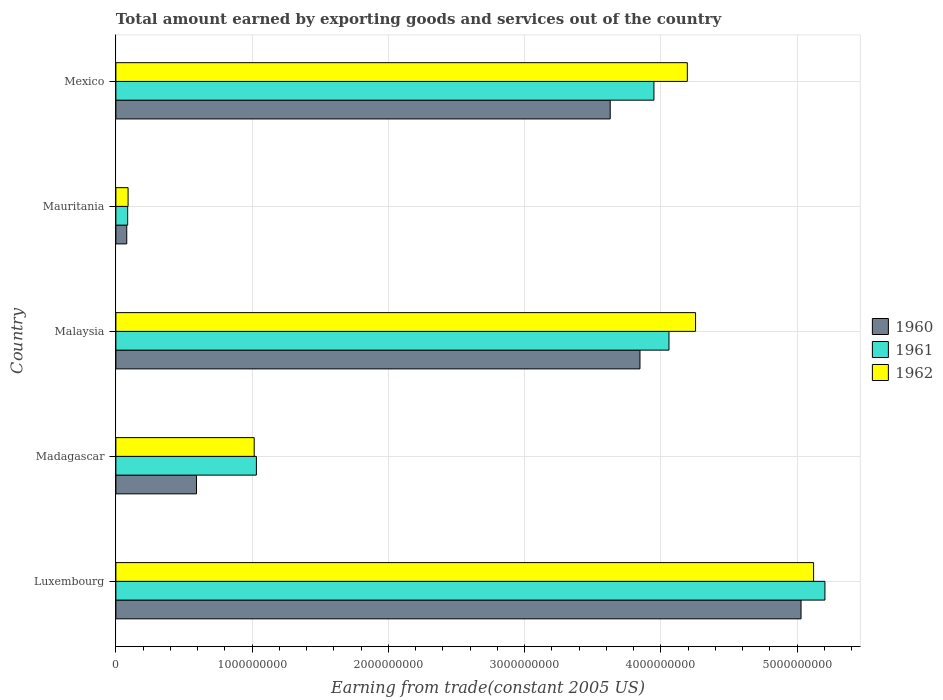Are the number of bars on each tick of the Y-axis equal?
Provide a short and direct response. Yes. How many bars are there on the 2nd tick from the top?
Make the answer very short. 3. What is the label of the 5th group of bars from the top?
Your answer should be compact. Luxembourg. What is the total amount earned by exporting goods and services in 1961 in Madagascar?
Ensure brevity in your answer.  1.03e+09. Across all countries, what is the maximum total amount earned by exporting goods and services in 1962?
Your response must be concise. 5.12e+09. Across all countries, what is the minimum total amount earned by exporting goods and services in 1962?
Your answer should be very brief. 8.95e+07. In which country was the total amount earned by exporting goods and services in 1961 maximum?
Your response must be concise. Luxembourg. In which country was the total amount earned by exporting goods and services in 1962 minimum?
Your answer should be compact. Mauritania. What is the total total amount earned by exporting goods and services in 1960 in the graph?
Your answer should be compact. 1.32e+1. What is the difference between the total amount earned by exporting goods and services in 1961 in Madagascar and that in Mexico?
Keep it short and to the point. -2.92e+09. What is the difference between the total amount earned by exporting goods and services in 1960 in Luxembourg and the total amount earned by exporting goods and services in 1962 in Mexico?
Keep it short and to the point. 8.35e+08. What is the average total amount earned by exporting goods and services in 1962 per country?
Offer a terse response. 2.94e+09. What is the difference between the total amount earned by exporting goods and services in 1962 and total amount earned by exporting goods and services in 1960 in Luxembourg?
Make the answer very short. 9.22e+07. In how many countries, is the total amount earned by exporting goods and services in 1961 greater than 4200000000 US$?
Keep it short and to the point. 1. What is the ratio of the total amount earned by exporting goods and services in 1962 in Malaysia to that in Mauritania?
Offer a very short reply. 47.53. Is the total amount earned by exporting goods and services in 1961 in Madagascar less than that in Malaysia?
Your answer should be compact. Yes. Is the difference between the total amount earned by exporting goods and services in 1962 in Malaysia and Mauritania greater than the difference between the total amount earned by exporting goods and services in 1960 in Malaysia and Mauritania?
Give a very brief answer. Yes. What is the difference between the highest and the second highest total amount earned by exporting goods and services in 1960?
Offer a terse response. 1.18e+09. What is the difference between the highest and the lowest total amount earned by exporting goods and services in 1961?
Provide a short and direct response. 5.12e+09. In how many countries, is the total amount earned by exporting goods and services in 1960 greater than the average total amount earned by exporting goods and services in 1960 taken over all countries?
Make the answer very short. 3. What does the 1st bar from the top in Malaysia represents?
Make the answer very short. 1962. What does the 3rd bar from the bottom in Mexico represents?
Offer a terse response. 1962. Is it the case that in every country, the sum of the total amount earned by exporting goods and services in 1960 and total amount earned by exporting goods and services in 1961 is greater than the total amount earned by exporting goods and services in 1962?
Provide a succinct answer. Yes. How many countries are there in the graph?
Keep it short and to the point. 5. What is the difference between two consecutive major ticks on the X-axis?
Your answer should be compact. 1.00e+09. Are the values on the major ticks of X-axis written in scientific E-notation?
Your response must be concise. No. What is the title of the graph?
Make the answer very short. Total amount earned by exporting goods and services out of the country. What is the label or title of the X-axis?
Your response must be concise. Earning from trade(constant 2005 US). What is the label or title of the Y-axis?
Provide a succinct answer. Country. What is the Earning from trade(constant 2005 US) of 1960 in Luxembourg?
Offer a very short reply. 5.03e+09. What is the Earning from trade(constant 2005 US) of 1961 in Luxembourg?
Your answer should be compact. 5.20e+09. What is the Earning from trade(constant 2005 US) in 1962 in Luxembourg?
Give a very brief answer. 5.12e+09. What is the Earning from trade(constant 2005 US) of 1960 in Madagascar?
Your answer should be very brief. 5.92e+08. What is the Earning from trade(constant 2005 US) of 1961 in Madagascar?
Your answer should be very brief. 1.03e+09. What is the Earning from trade(constant 2005 US) in 1962 in Madagascar?
Provide a succinct answer. 1.02e+09. What is the Earning from trade(constant 2005 US) in 1960 in Malaysia?
Your answer should be very brief. 3.85e+09. What is the Earning from trade(constant 2005 US) of 1961 in Malaysia?
Keep it short and to the point. 4.06e+09. What is the Earning from trade(constant 2005 US) in 1962 in Malaysia?
Your response must be concise. 4.25e+09. What is the Earning from trade(constant 2005 US) in 1960 in Mauritania?
Offer a terse response. 7.97e+07. What is the Earning from trade(constant 2005 US) of 1961 in Mauritania?
Provide a short and direct response. 8.64e+07. What is the Earning from trade(constant 2005 US) in 1962 in Mauritania?
Your response must be concise. 8.95e+07. What is the Earning from trade(constant 2005 US) of 1960 in Mexico?
Your response must be concise. 3.63e+09. What is the Earning from trade(constant 2005 US) in 1961 in Mexico?
Your answer should be compact. 3.95e+09. What is the Earning from trade(constant 2005 US) of 1962 in Mexico?
Ensure brevity in your answer.  4.19e+09. Across all countries, what is the maximum Earning from trade(constant 2005 US) in 1960?
Your answer should be very brief. 5.03e+09. Across all countries, what is the maximum Earning from trade(constant 2005 US) in 1961?
Make the answer very short. 5.20e+09. Across all countries, what is the maximum Earning from trade(constant 2005 US) in 1962?
Provide a short and direct response. 5.12e+09. Across all countries, what is the minimum Earning from trade(constant 2005 US) of 1960?
Your response must be concise. 7.97e+07. Across all countries, what is the minimum Earning from trade(constant 2005 US) in 1961?
Offer a very short reply. 8.64e+07. Across all countries, what is the minimum Earning from trade(constant 2005 US) in 1962?
Your answer should be very brief. 8.95e+07. What is the total Earning from trade(constant 2005 US) of 1960 in the graph?
Ensure brevity in your answer.  1.32e+1. What is the total Earning from trade(constant 2005 US) of 1961 in the graph?
Your answer should be very brief. 1.43e+1. What is the total Earning from trade(constant 2005 US) in 1962 in the graph?
Keep it short and to the point. 1.47e+1. What is the difference between the Earning from trade(constant 2005 US) in 1960 in Luxembourg and that in Madagascar?
Give a very brief answer. 4.44e+09. What is the difference between the Earning from trade(constant 2005 US) in 1961 in Luxembourg and that in Madagascar?
Provide a succinct answer. 4.17e+09. What is the difference between the Earning from trade(constant 2005 US) of 1962 in Luxembourg and that in Madagascar?
Offer a very short reply. 4.11e+09. What is the difference between the Earning from trade(constant 2005 US) in 1960 in Luxembourg and that in Malaysia?
Ensure brevity in your answer.  1.18e+09. What is the difference between the Earning from trade(constant 2005 US) in 1961 in Luxembourg and that in Malaysia?
Provide a short and direct response. 1.14e+09. What is the difference between the Earning from trade(constant 2005 US) of 1962 in Luxembourg and that in Malaysia?
Give a very brief answer. 8.66e+08. What is the difference between the Earning from trade(constant 2005 US) in 1960 in Luxembourg and that in Mauritania?
Provide a succinct answer. 4.95e+09. What is the difference between the Earning from trade(constant 2005 US) of 1961 in Luxembourg and that in Mauritania?
Keep it short and to the point. 5.12e+09. What is the difference between the Earning from trade(constant 2005 US) of 1962 in Luxembourg and that in Mauritania?
Keep it short and to the point. 5.03e+09. What is the difference between the Earning from trade(constant 2005 US) in 1960 in Luxembourg and that in Mexico?
Your response must be concise. 1.40e+09. What is the difference between the Earning from trade(constant 2005 US) in 1961 in Luxembourg and that in Mexico?
Make the answer very short. 1.26e+09. What is the difference between the Earning from trade(constant 2005 US) in 1962 in Luxembourg and that in Mexico?
Your answer should be compact. 9.27e+08. What is the difference between the Earning from trade(constant 2005 US) of 1960 in Madagascar and that in Malaysia?
Provide a short and direct response. -3.26e+09. What is the difference between the Earning from trade(constant 2005 US) in 1961 in Madagascar and that in Malaysia?
Offer a terse response. -3.03e+09. What is the difference between the Earning from trade(constant 2005 US) in 1962 in Madagascar and that in Malaysia?
Make the answer very short. -3.24e+09. What is the difference between the Earning from trade(constant 2005 US) in 1960 in Madagascar and that in Mauritania?
Your answer should be compact. 5.12e+08. What is the difference between the Earning from trade(constant 2005 US) of 1961 in Madagascar and that in Mauritania?
Give a very brief answer. 9.45e+08. What is the difference between the Earning from trade(constant 2005 US) of 1962 in Madagascar and that in Mauritania?
Your answer should be compact. 9.26e+08. What is the difference between the Earning from trade(constant 2005 US) of 1960 in Madagascar and that in Mexico?
Your response must be concise. -3.04e+09. What is the difference between the Earning from trade(constant 2005 US) of 1961 in Madagascar and that in Mexico?
Your answer should be compact. -2.92e+09. What is the difference between the Earning from trade(constant 2005 US) of 1962 in Madagascar and that in Mexico?
Ensure brevity in your answer.  -3.18e+09. What is the difference between the Earning from trade(constant 2005 US) in 1960 in Malaysia and that in Mauritania?
Make the answer very short. 3.77e+09. What is the difference between the Earning from trade(constant 2005 US) in 1961 in Malaysia and that in Mauritania?
Offer a terse response. 3.97e+09. What is the difference between the Earning from trade(constant 2005 US) in 1962 in Malaysia and that in Mauritania?
Provide a short and direct response. 4.17e+09. What is the difference between the Earning from trade(constant 2005 US) of 1960 in Malaysia and that in Mexico?
Your response must be concise. 2.18e+08. What is the difference between the Earning from trade(constant 2005 US) in 1961 in Malaysia and that in Mexico?
Provide a succinct answer. 1.10e+08. What is the difference between the Earning from trade(constant 2005 US) of 1962 in Malaysia and that in Mexico?
Provide a succinct answer. 6.04e+07. What is the difference between the Earning from trade(constant 2005 US) of 1960 in Mauritania and that in Mexico?
Make the answer very short. -3.55e+09. What is the difference between the Earning from trade(constant 2005 US) of 1961 in Mauritania and that in Mexico?
Your response must be concise. -3.86e+09. What is the difference between the Earning from trade(constant 2005 US) of 1962 in Mauritania and that in Mexico?
Provide a short and direct response. -4.10e+09. What is the difference between the Earning from trade(constant 2005 US) of 1960 in Luxembourg and the Earning from trade(constant 2005 US) of 1961 in Madagascar?
Ensure brevity in your answer.  4.00e+09. What is the difference between the Earning from trade(constant 2005 US) of 1960 in Luxembourg and the Earning from trade(constant 2005 US) of 1962 in Madagascar?
Give a very brief answer. 4.01e+09. What is the difference between the Earning from trade(constant 2005 US) in 1961 in Luxembourg and the Earning from trade(constant 2005 US) in 1962 in Madagascar?
Provide a short and direct response. 4.19e+09. What is the difference between the Earning from trade(constant 2005 US) of 1960 in Luxembourg and the Earning from trade(constant 2005 US) of 1961 in Malaysia?
Keep it short and to the point. 9.69e+08. What is the difference between the Earning from trade(constant 2005 US) in 1960 in Luxembourg and the Earning from trade(constant 2005 US) in 1962 in Malaysia?
Your answer should be very brief. 7.74e+08. What is the difference between the Earning from trade(constant 2005 US) in 1961 in Luxembourg and the Earning from trade(constant 2005 US) in 1962 in Malaysia?
Ensure brevity in your answer.  9.49e+08. What is the difference between the Earning from trade(constant 2005 US) in 1960 in Luxembourg and the Earning from trade(constant 2005 US) in 1961 in Mauritania?
Ensure brevity in your answer.  4.94e+09. What is the difference between the Earning from trade(constant 2005 US) of 1960 in Luxembourg and the Earning from trade(constant 2005 US) of 1962 in Mauritania?
Provide a short and direct response. 4.94e+09. What is the difference between the Earning from trade(constant 2005 US) of 1961 in Luxembourg and the Earning from trade(constant 2005 US) of 1962 in Mauritania?
Ensure brevity in your answer.  5.11e+09. What is the difference between the Earning from trade(constant 2005 US) of 1960 in Luxembourg and the Earning from trade(constant 2005 US) of 1961 in Mexico?
Provide a short and direct response. 1.08e+09. What is the difference between the Earning from trade(constant 2005 US) of 1960 in Luxembourg and the Earning from trade(constant 2005 US) of 1962 in Mexico?
Offer a very short reply. 8.35e+08. What is the difference between the Earning from trade(constant 2005 US) in 1961 in Luxembourg and the Earning from trade(constant 2005 US) in 1962 in Mexico?
Provide a short and direct response. 1.01e+09. What is the difference between the Earning from trade(constant 2005 US) in 1960 in Madagascar and the Earning from trade(constant 2005 US) in 1961 in Malaysia?
Your answer should be compact. -3.47e+09. What is the difference between the Earning from trade(constant 2005 US) in 1960 in Madagascar and the Earning from trade(constant 2005 US) in 1962 in Malaysia?
Keep it short and to the point. -3.66e+09. What is the difference between the Earning from trade(constant 2005 US) of 1961 in Madagascar and the Earning from trade(constant 2005 US) of 1962 in Malaysia?
Keep it short and to the point. -3.22e+09. What is the difference between the Earning from trade(constant 2005 US) of 1960 in Madagascar and the Earning from trade(constant 2005 US) of 1961 in Mauritania?
Your answer should be very brief. 5.05e+08. What is the difference between the Earning from trade(constant 2005 US) of 1960 in Madagascar and the Earning from trade(constant 2005 US) of 1962 in Mauritania?
Offer a very short reply. 5.02e+08. What is the difference between the Earning from trade(constant 2005 US) in 1961 in Madagascar and the Earning from trade(constant 2005 US) in 1962 in Mauritania?
Keep it short and to the point. 9.42e+08. What is the difference between the Earning from trade(constant 2005 US) in 1960 in Madagascar and the Earning from trade(constant 2005 US) in 1961 in Mexico?
Offer a very short reply. -3.36e+09. What is the difference between the Earning from trade(constant 2005 US) of 1960 in Madagascar and the Earning from trade(constant 2005 US) of 1962 in Mexico?
Your answer should be very brief. -3.60e+09. What is the difference between the Earning from trade(constant 2005 US) in 1961 in Madagascar and the Earning from trade(constant 2005 US) in 1962 in Mexico?
Provide a short and direct response. -3.16e+09. What is the difference between the Earning from trade(constant 2005 US) of 1960 in Malaysia and the Earning from trade(constant 2005 US) of 1961 in Mauritania?
Offer a terse response. 3.76e+09. What is the difference between the Earning from trade(constant 2005 US) of 1960 in Malaysia and the Earning from trade(constant 2005 US) of 1962 in Mauritania?
Your response must be concise. 3.76e+09. What is the difference between the Earning from trade(constant 2005 US) of 1961 in Malaysia and the Earning from trade(constant 2005 US) of 1962 in Mauritania?
Provide a succinct answer. 3.97e+09. What is the difference between the Earning from trade(constant 2005 US) in 1960 in Malaysia and the Earning from trade(constant 2005 US) in 1961 in Mexico?
Provide a short and direct response. -1.02e+08. What is the difference between the Earning from trade(constant 2005 US) of 1960 in Malaysia and the Earning from trade(constant 2005 US) of 1962 in Mexico?
Offer a terse response. -3.48e+08. What is the difference between the Earning from trade(constant 2005 US) of 1961 in Malaysia and the Earning from trade(constant 2005 US) of 1962 in Mexico?
Keep it short and to the point. -1.35e+08. What is the difference between the Earning from trade(constant 2005 US) in 1960 in Mauritania and the Earning from trade(constant 2005 US) in 1961 in Mexico?
Your answer should be very brief. -3.87e+09. What is the difference between the Earning from trade(constant 2005 US) of 1960 in Mauritania and the Earning from trade(constant 2005 US) of 1962 in Mexico?
Your response must be concise. -4.11e+09. What is the difference between the Earning from trade(constant 2005 US) in 1961 in Mauritania and the Earning from trade(constant 2005 US) in 1962 in Mexico?
Provide a short and direct response. -4.11e+09. What is the average Earning from trade(constant 2005 US) in 1960 per country?
Give a very brief answer. 2.64e+09. What is the average Earning from trade(constant 2005 US) in 1961 per country?
Offer a very short reply. 2.87e+09. What is the average Earning from trade(constant 2005 US) in 1962 per country?
Offer a terse response. 2.94e+09. What is the difference between the Earning from trade(constant 2005 US) in 1960 and Earning from trade(constant 2005 US) in 1961 in Luxembourg?
Your response must be concise. -1.75e+08. What is the difference between the Earning from trade(constant 2005 US) in 1960 and Earning from trade(constant 2005 US) in 1962 in Luxembourg?
Make the answer very short. -9.22e+07. What is the difference between the Earning from trade(constant 2005 US) of 1961 and Earning from trade(constant 2005 US) of 1962 in Luxembourg?
Offer a terse response. 8.31e+07. What is the difference between the Earning from trade(constant 2005 US) of 1960 and Earning from trade(constant 2005 US) of 1961 in Madagascar?
Provide a short and direct response. -4.40e+08. What is the difference between the Earning from trade(constant 2005 US) in 1960 and Earning from trade(constant 2005 US) in 1962 in Madagascar?
Make the answer very short. -4.24e+08. What is the difference between the Earning from trade(constant 2005 US) of 1961 and Earning from trade(constant 2005 US) of 1962 in Madagascar?
Keep it short and to the point. 1.61e+07. What is the difference between the Earning from trade(constant 2005 US) of 1960 and Earning from trade(constant 2005 US) of 1961 in Malaysia?
Offer a terse response. -2.13e+08. What is the difference between the Earning from trade(constant 2005 US) in 1960 and Earning from trade(constant 2005 US) in 1962 in Malaysia?
Your answer should be very brief. -4.08e+08. What is the difference between the Earning from trade(constant 2005 US) in 1961 and Earning from trade(constant 2005 US) in 1962 in Malaysia?
Provide a short and direct response. -1.95e+08. What is the difference between the Earning from trade(constant 2005 US) of 1960 and Earning from trade(constant 2005 US) of 1961 in Mauritania?
Provide a short and direct response. -6.74e+06. What is the difference between the Earning from trade(constant 2005 US) in 1960 and Earning from trade(constant 2005 US) in 1962 in Mauritania?
Offer a very short reply. -9.81e+06. What is the difference between the Earning from trade(constant 2005 US) in 1961 and Earning from trade(constant 2005 US) in 1962 in Mauritania?
Provide a succinct answer. -3.07e+06. What is the difference between the Earning from trade(constant 2005 US) of 1960 and Earning from trade(constant 2005 US) of 1961 in Mexico?
Give a very brief answer. -3.21e+08. What is the difference between the Earning from trade(constant 2005 US) in 1960 and Earning from trade(constant 2005 US) in 1962 in Mexico?
Your answer should be very brief. -5.66e+08. What is the difference between the Earning from trade(constant 2005 US) in 1961 and Earning from trade(constant 2005 US) in 1962 in Mexico?
Provide a succinct answer. -2.45e+08. What is the ratio of the Earning from trade(constant 2005 US) in 1960 in Luxembourg to that in Madagascar?
Ensure brevity in your answer.  8.5. What is the ratio of the Earning from trade(constant 2005 US) in 1961 in Luxembourg to that in Madagascar?
Make the answer very short. 5.05. What is the ratio of the Earning from trade(constant 2005 US) in 1962 in Luxembourg to that in Madagascar?
Keep it short and to the point. 5.04. What is the ratio of the Earning from trade(constant 2005 US) in 1960 in Luxembourg to that in Malaysia?
Offer a terse response. 1.31. What is the ratio of the Earning from trade(constant 2005 US) of 1961 in Luxembourg to that in Malaysia?
Your response must be concise. 1.28. What is the ratio of the Earning from trade(constant 2005 US) of 1962 in Luxembourg to that in Malaysia?
Your response must be concise. 1.2. What is the ratio of the Earning from trade(constant 2005 US) in 1960 in Luxembourg to that in Mauritania?
Ensure brevity in your answer.  63.1. What is the ratio of the Earning from trade(constant 2005 US) in 1961 in Luxembourg to that in Mauritania?
Provide a succinct answer. 60.2. What is the ratio of the Earning from trade(constant 2005 US) of 1962 in Luxembourg to that in Mauritania?
Provide a short and direct response. 57.21. What is the ratio of the Earning from trade(constant 2005 US) of 1960 in Luxembourg to that in Mexico?
Offer a terse response. 1.39. What is the ratio of the Earning from trade(constant 2005 US) of 1961 in Luxembourg to that in Mexico?
Provide a short and direct response. 1.32. What is the ratio of the Earning from trade(constant 2005 US) in 1962 in Luxembourg to that in Mexico?
Your answer should be compact. 1.22. What is the ratio of the Earning from trade(constant 2005 US) in 1960 in Madagascar to that in Malaysia?
Keep it short and to the point. 0.15. What is the ratio of the Earning from trade(constant 2005 US) of 1961 in Madagascar to that in Malaysia?
Provide a short and direct response. 0.25. What is the ratio of the Earning from trade(constant 2005 US) of 1962 in Madagascar to that in Malaysia?
Ensure brevity in your answer.  0.24. What is the ratio of the Earning from trade(constant 2005 US) in 1960 in Madagascar to that in Mauritania?
Offer a very short reply. 7.42. What is the ratio of the Earning from trade(constant 2005 US) of 1961 in Madagascar to that in Mauritania?
Your answer should be compact. 11.93. What is the ratio of the Earning from trade(constant 2005 US) in 1962 in Madagascar to that in Mauritania?
Your response must be concise. 11.34. What is the ratio of the Earning from trade(constant 2005 US) of 1960 in Madagascar to that in Mexico?
Make the answer very short. 0.16. What is the ratio of the Earning from trade(constant 2005 US) in 1961 in Madagascar to that in Mexico?
Keep it short and to the point. 0.26. What is the ratio of the Earning from trade(constant 2005 US) in 1962 in Madagascar to that in Mexico?
Keep it short and to the point. 0.24. What is the ratio of the Earning from trade(constant 2005 US) in 1960 in Malaysia to that in Mauritania?
Offer a terse response. 48.26. What is the ratio of the Earning from trade(constant 2005 US) in 1961 in Malaysia to that in Mauritania?
Your answer should be very brief. 46.96. What is the ratio of the Earning from trade(constant 2005 US) in 1962 in Malaysia to that in Mauritania?
Keep it short and to the point. 47.53. What is the ratio of the Earning from trade(constant 2005 US) in 1960 in Malaysia to that in Mexico?
Your response must be concise. 1.06. What is the ratio of the Earning from trade(constant 2005 US) in 1961 in Malaysia to that in Mexico?
Keep it short and to the point. 1.03. What is the ratio of the Earning from trade(constant 2005 US) of 1962 in Malaysia to that in Mexico?
Provide a short and direct response. 1.01. What is the ratio of the Earning from trade(constant 2005 US) of 1960 in Mauritania to that in Mexico?
Provide a short and direct response. 0.02. What is the ratio of the Earning from trade(constant 2005 US) in 1961 in Mauritania to that in Mexico?
Keep it short and to the point. 0.02. What is the ratio of the Earning from trade(constant 2005 US) of 1962 in Mauritania to that in Mexico?
Ensure brevity in your answer.  0.02. What is the difference between the highest and the second highest Earning from trade(constant 2005 US) in 1960?
Provide a succinct answer. 1.18e+09. What is the difference between the highest and the second highest Earning from trade(constant 2005 US) of 1961?
Give a very brief answer. 1.14e+09. What is the difference between the highest and the second highest Earning from trade(constant 2005 US) in 1962?
Ensure brevity in your answer.  8.66e+08. What is the difference between the highest and the lowest Earning from trade(constant 2005 US) of 1960?
Provide a succinct answer. 4.95e+09. What is the difference between the highest and the lowest Earning from trade(constant 2005 US) in 1961?
Provide a short and direct response. 5.12e+09. What is the difference between the highest and the lowest Earning from trade(constant 2005 US) of 1962?
Give a very brief answer. 5.03e+09. 